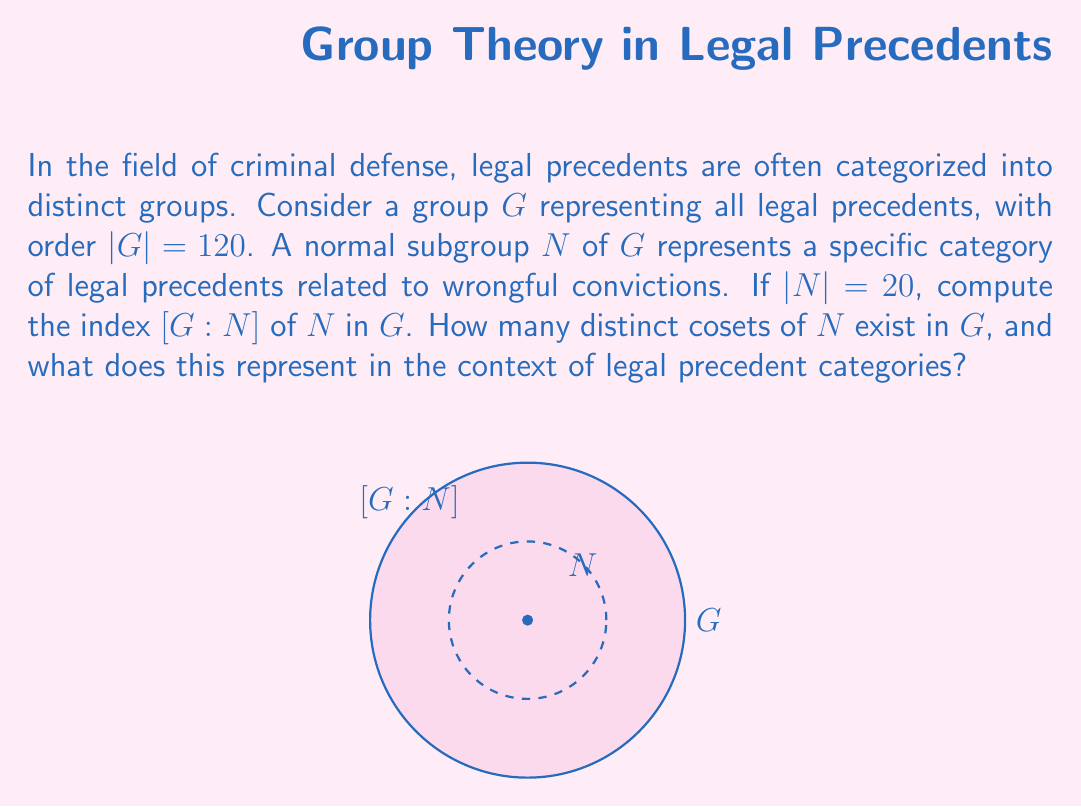What is the answer to this math problem? To solve this problem, we'll follow these steps:

1) Recall the definition of the index of a subgroup: For a group $G$ and its subgroup $N$, the index $[G:N]$ is the number of distinct left (or right) cosets of $N$ in $G$.

2) There's a fundamental theorem in group theory that relates the order of the group, the order of the subgroup, and the index:

   $$|G| = |N| \cdot [G:N]$$

3) We're given:
   $|G| = 120$ (order of the full group of legal precedents)
   $|N| = 20$ (order of the subgroup representing wrongful conviction precedents)

4) Substituting these values into the equation:

   $$120 = 20 \cdot [G:N]$$

5) Solving for $[G:N]$:

   $$[G:N] = \frac{120}{20} = 6$$

6) Therefore, the index $[G:N]$ is 6, which means there are 6 distinct cosets of $N$ in $G$.

In the context of legal precedent categories, this result indicates that the full set of legal precedents ($G$) can be divided into 6 distinct categories, with wrongful conviction precedents ($N$) being one of these categories. Each coset represents a unique category of legal precedents that are related to each other in a way that's analogous to how wrongful conviction precedents are related within their category.
Answer: $[G:N] = 6$ 